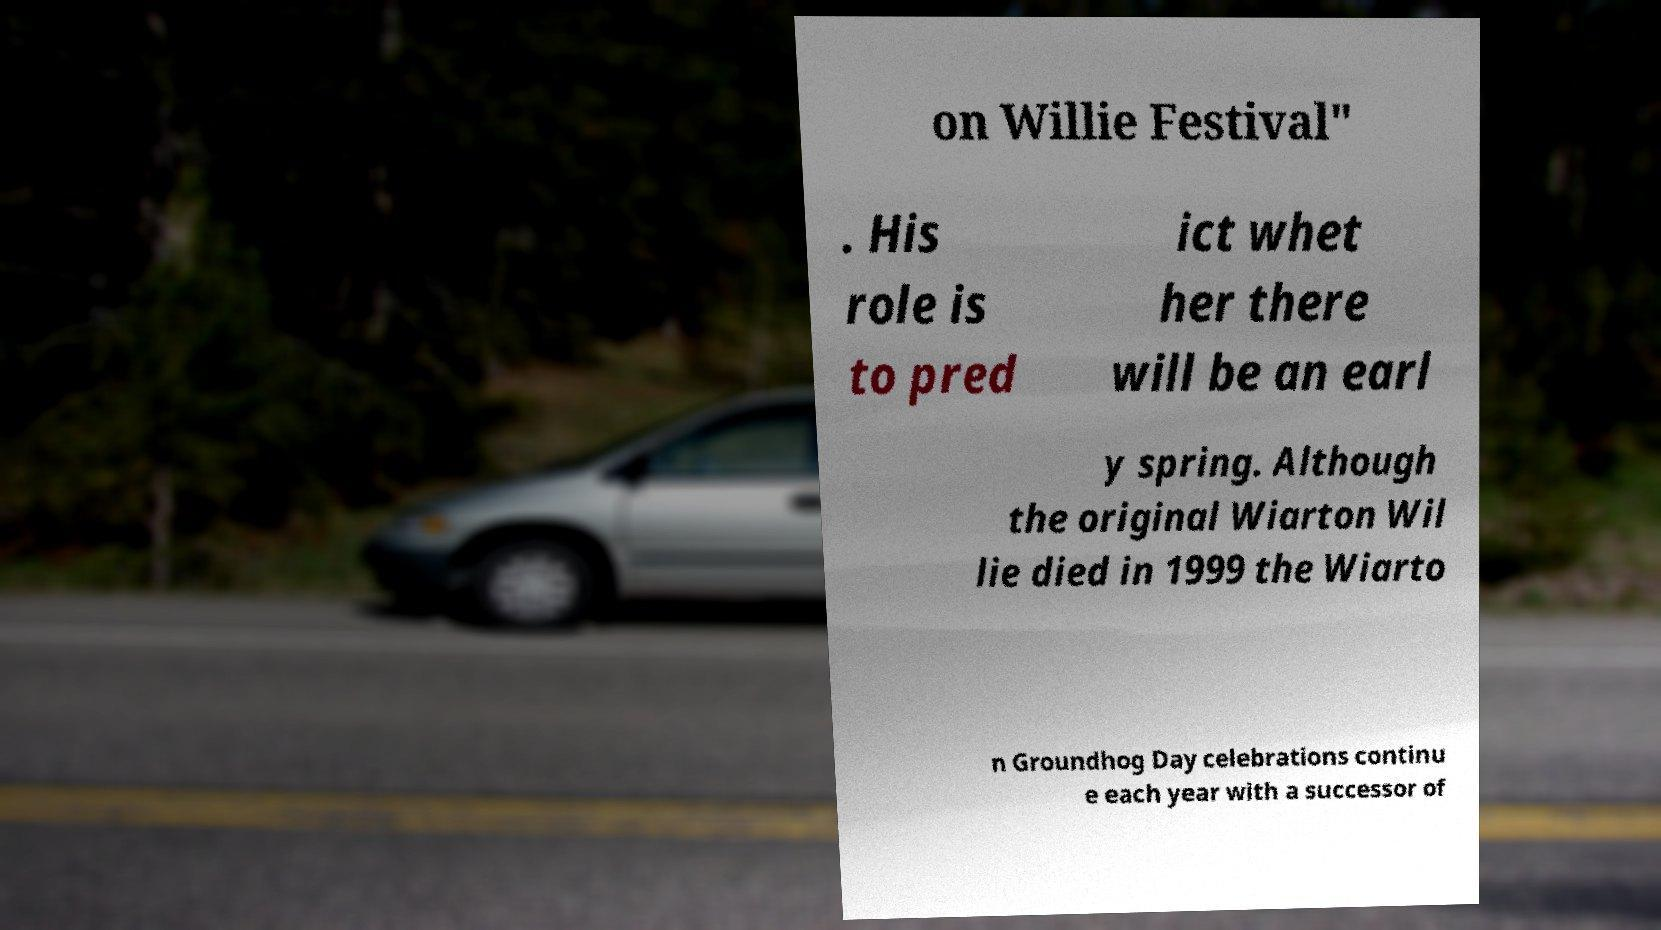There's text embedded in this image that I need extracted. Can you transcribe it verbatim? on Willie Festival" . His role is to pred ict whet her there will be an earl y spring. Although the original Wiarton Wil lie died in 1999 the Wiarto n Groundhog Day celebrations continu e each year with a successor of 